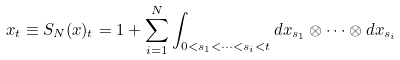<formula> <loc_0><loc_0><loc_500><loc_500>x _ { t } \equiv S _ { N } ( x ) _ { t } = 1 + \sum _ { i = 1 } ^ { N } \int _ { 0 < s _ { 1 } < \dots < s _ { i } < t } d x _ { s _ { 1 } } \otimes \dots \otimes d x _ { s _ { i } }</formula> 